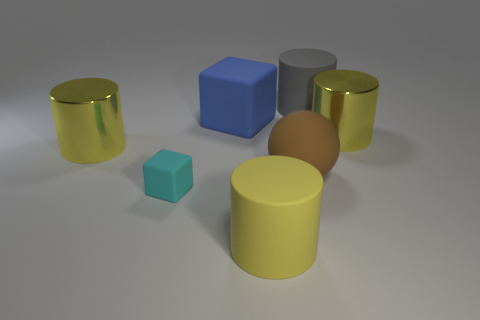Is there anything else that has the same shape as the big brown matte thing?
Make the answer very short. No. Are there more tiny things than small blue matte cylinders?
Provide a succinct answer. Yes. What number of objects are big things behind the big brown object or big cylinders on the right side of the big blue matte object?
Offer a terse response. 5. There is a sphere that is the same size as the yellow rubber cylinder; what color is it?
Your response must be concise. Brown. Are the large block and the cyan cube made of the same material?
Your response must be concise. Yes. What material is the large thing that is on the right side of the gray object that is behind the cyan matte object?
Your answer should be compact. Metal. Is the number of cyan cubes to the right of the small cyan rubber block greater than the number of cyan rubber cubes?
Make the answer very short. No. What number of other things are the same size as the yellow matte thing?
Your response must be concise. 5. Does the big rubber block have the same color as the small block?
Your answer should be compact. No. What is the color of the metallic cylinder that is on the left side of the large yellow metal object to the right of the cylinder in front of the large brown object?
Your answer should be very brief. Yellow. 